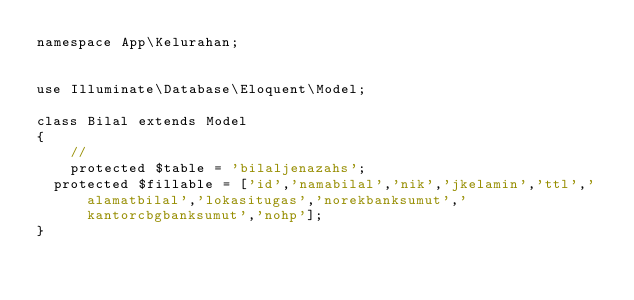Convert code to text. <code><loc_0><loc_0><loc_500><loc_500><_PHP_>namespace App\Kelurahan;


use Illuminate\Database\Eloquent\Model;

class Bilal extends Model
{
    //
    protected $table = 'bilaljenazahs';
	protected $fillable = ['id','namabilal','nik','jkelamin','ttl','alamatbilal','lokasitugas','norekbanksumut','kantorcbgbanksumut','nohp'];
}
</code> 